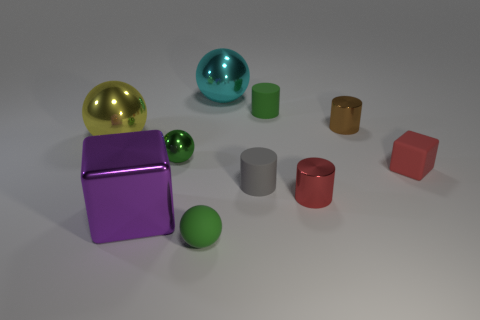How many green spheres must be subtracted to get 1 green spheres? 1 Subtract all large cyan metal balls. How many balls are left? 3 Subtract all green cylinders. How many cylinders are left? 3 Subtract all purple cylinders. How many green spheres are left? 2 Subtract 2 spheres. How many spheres are left? 2 Subtract 1 yellow balls. How many objects are left? 9 Subtract all balls. How many objects are left? 6 Subtract all cyan cylinders. Subtract all red spheres. How many cylinders are left? 4 Subtract all small brown rubber cylinders. Subtract all brown metallic cylinders. How many objects are left? 9 Add 1 red cubes. How many red cubes are left? 2 